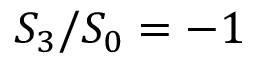Convert formula to latex. <formula><loc_0><loc_0><loc_500><loc_500>S _ { 3 } / S _ { 0 } = - 1</formula> 